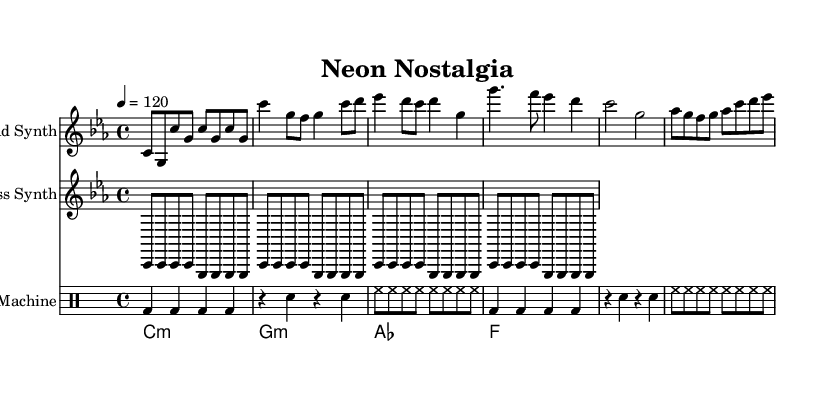What is the key signature of this music? The key signature is C minor, which contains three flats: B♭, E♭, and A♭. This information is indicated at the beginning of the score.
Answer: C minor What is the time signature of the piece? The time signature, shown at the beginning of the score, is 4/4, which means there are four beats in each measure.
Answer: 4/4 What is the tempo marking for the piece? The tempo marking is indicated as "4 = 120", which means that there are 120 beats per minute. This information is specified in the global section of the code.
Answer: 120 How many measures are in the lead synth section? The lead synth section consists of 12 measures, as indicated by the number of distinct musical phrases shown in the lead synth staff. Each set of music is separated by vertical lines called bar lines.
Answer: 12 What type of electronic synth is used for the bass line? The bass line is performed using a "Bass Synth" as labeled at the beginning of the bass synth staff.
Answer: Bass Synth What rhythmic pattern is used for the drum machine? The drum machine employs a repeating rhythm pattern consisting of bass drum and snare, using quarter notes and eighth notes, as shown in the drum machine staff.
Answer: Repeating rhythm What is the first chord played by the pad synth? The first chord played by the pad synth is C minor, indicated by the chord symbol at the beginning of the pad synth section.
Answer: C minor 